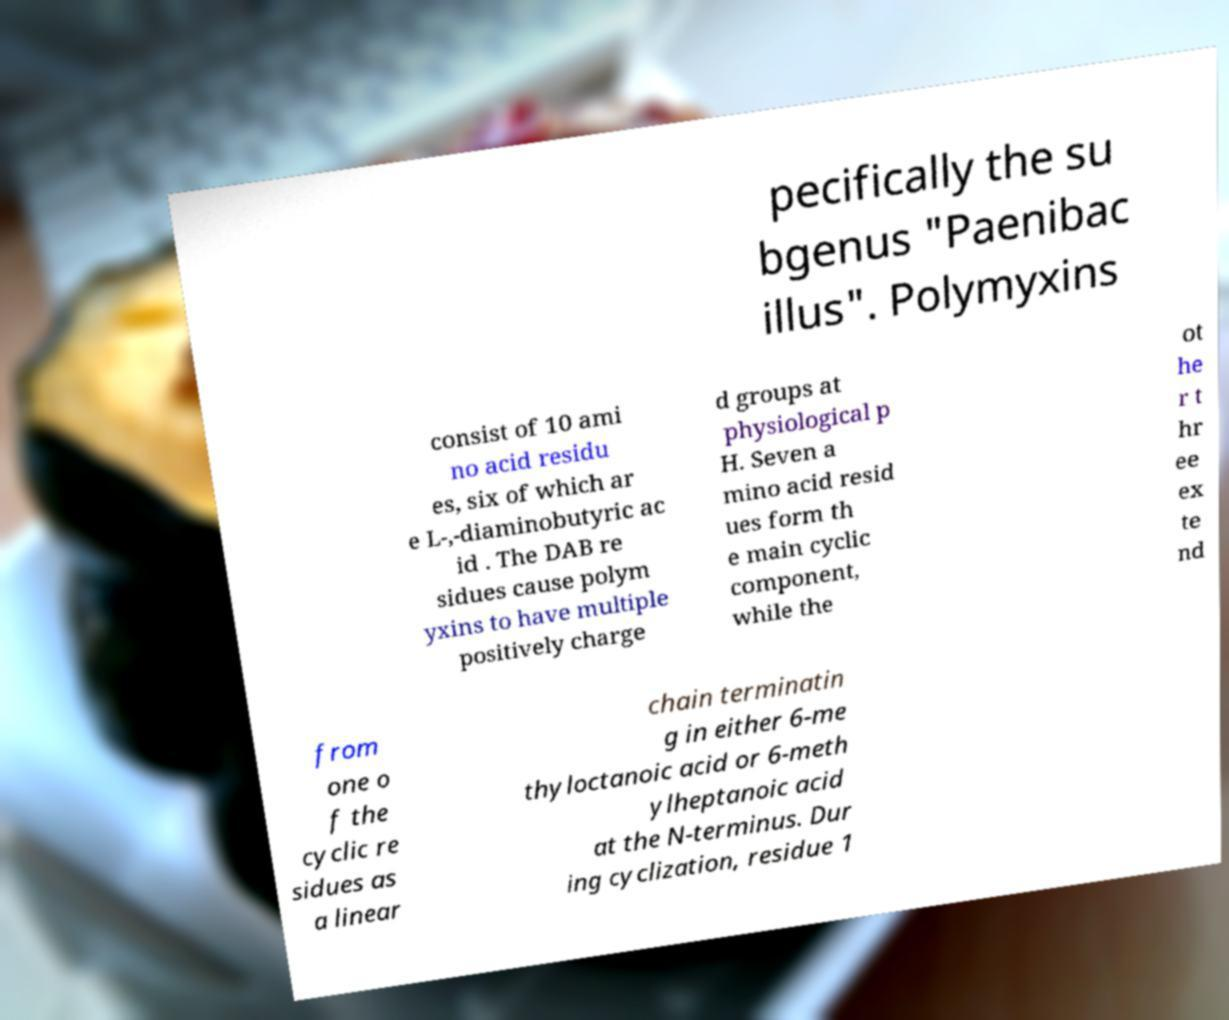Please read and relay the text visible in this image. What does it say? pecifically the su bgenus "Paenibac illus". Polymyxins consist of 10 ami no acid residu es, six of which ar e L-,-diaminobutyric ac id . The DAB re sidues cause polym yxins to have multiple positively charge d groups at physiological p H. Seven a mino acid resid ues form th e main cyclic component, while the ot he r t hr ee ex te nd from one o f the cyclic re sidues as a linear chain terminatin g in either 6-me thyloctanoic acid or 6-meth ylheptanoic acid at the N-terminus. Dur ing cyclization, residue 1 